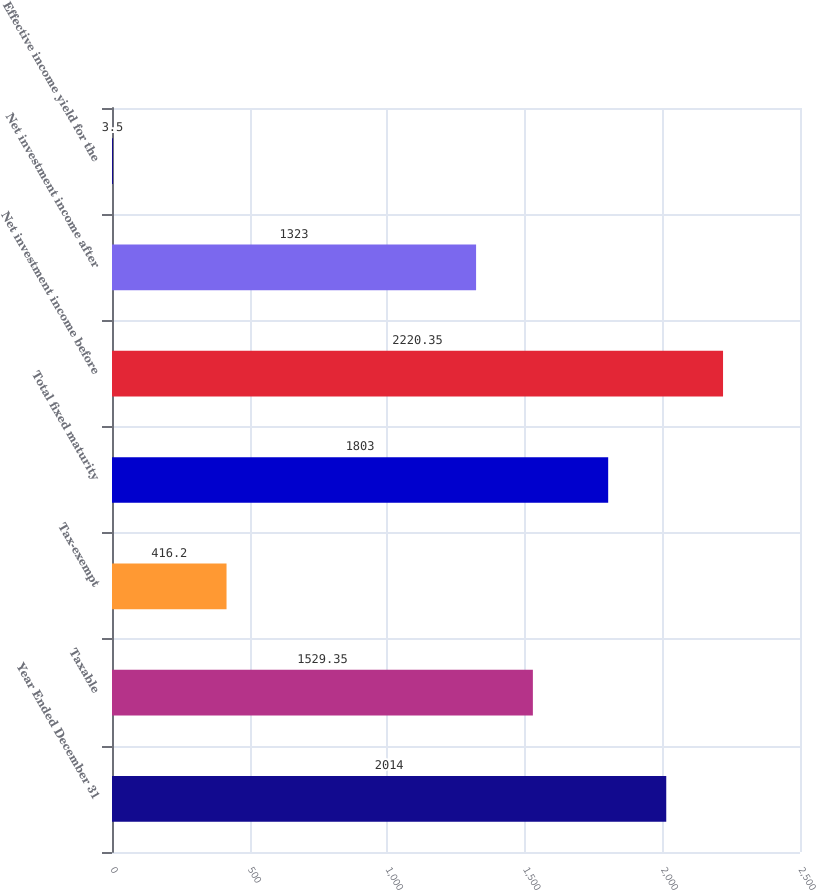<chart> <loc_0><loc_0><loc_500><loc_500><bar_chart><fcel>Year Ended December 31<fcel>Taxable<fcel>Tax-exempt<fcel>Total fixed maturity<fcel>Net investment income before<fcel>Net investment income after<fcel>Effective income yield for the<nl><fcel>2014<fcel>1529.35<fcel>416.2<fcel>1803<fcel>2220.35<fcel>1323<fcel>3.5<nl></chart> 